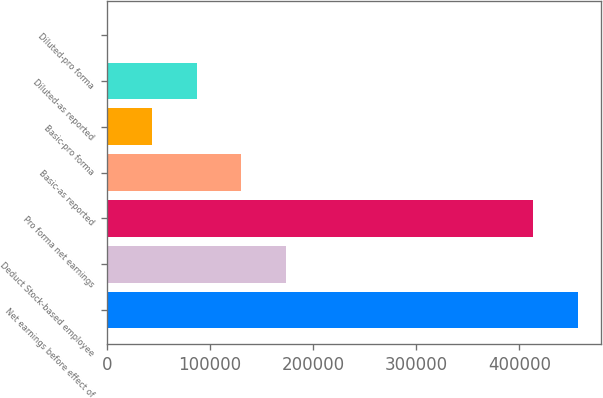<chart> <loc_0><loc_0><loc_500><loc_500><bar_chart><fcel>Net earnings before effect of<fcel>Deduct Stock-based employee<fcel>Pro forma net earnings<fcel>Basic-as reported<fcel>Basic-pro forma<fcel>Diluted-as reported<fcel>Diluted-pro forma<nl><fcel>456595<fcel>173657<fcel>413181<fcel>130243<fcel>43415.3<fcel>86829.3<fcel>1.33<nl></chart> 